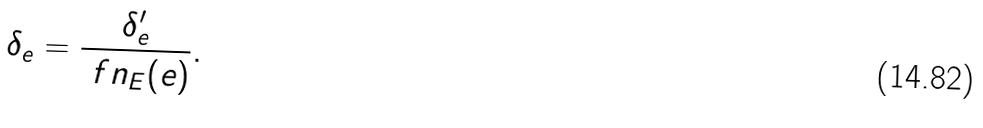Convert formula to latex. <formula><loc_0><loc_0><loc_500><loc_500>\delta _ { e } = \frac { \delta _ { e } ^ { \prime } } { \ f n _ { E } ( e ) } .</formula> 